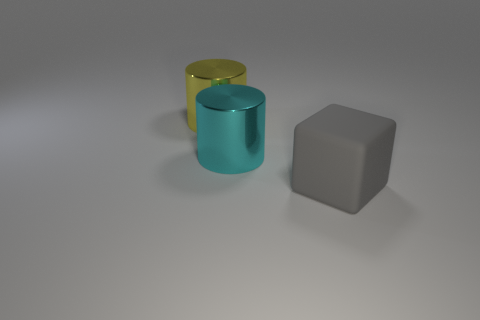What could be the purpose of these objects if they were in a real-life setting? If these objects were real, the cylindrical ones could be containers for storage or perhaps vases, while the cube might serve as a weighty paperweight or an artistic decor element due to its solid and geometric form. 